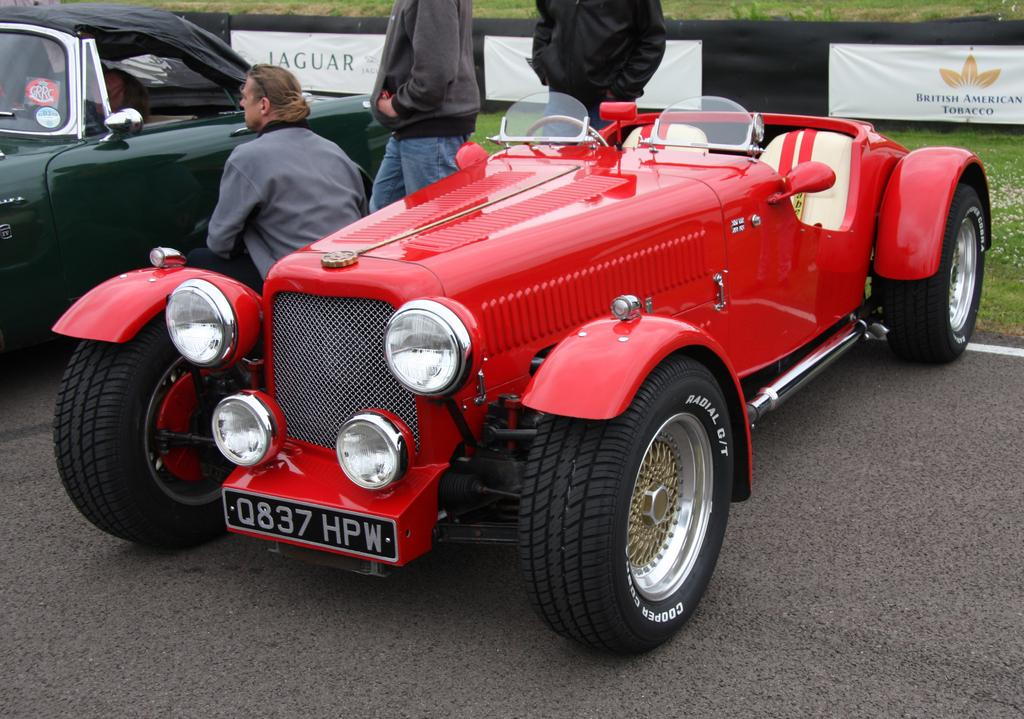What can be seen on the road in the image? There are cars on the road in the image. What else is present in the image besides the cars? There is a group of people in the image. What type of vegetation is visible in the background of the image? There is grass visible in the background of the image. What else can be seen in the background of the image? There are hoardings in the background of the image. Is there a yak visible in the image? No, there is no yak present in the image. What type of light can be seen illuminating the scene in the image? There is no specific mention of light in the provided facts, so we cannot determine the type of light in the image. 